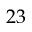<formula> <loc_0><loc_0><loc_500><loc_500>2 3</formula> 